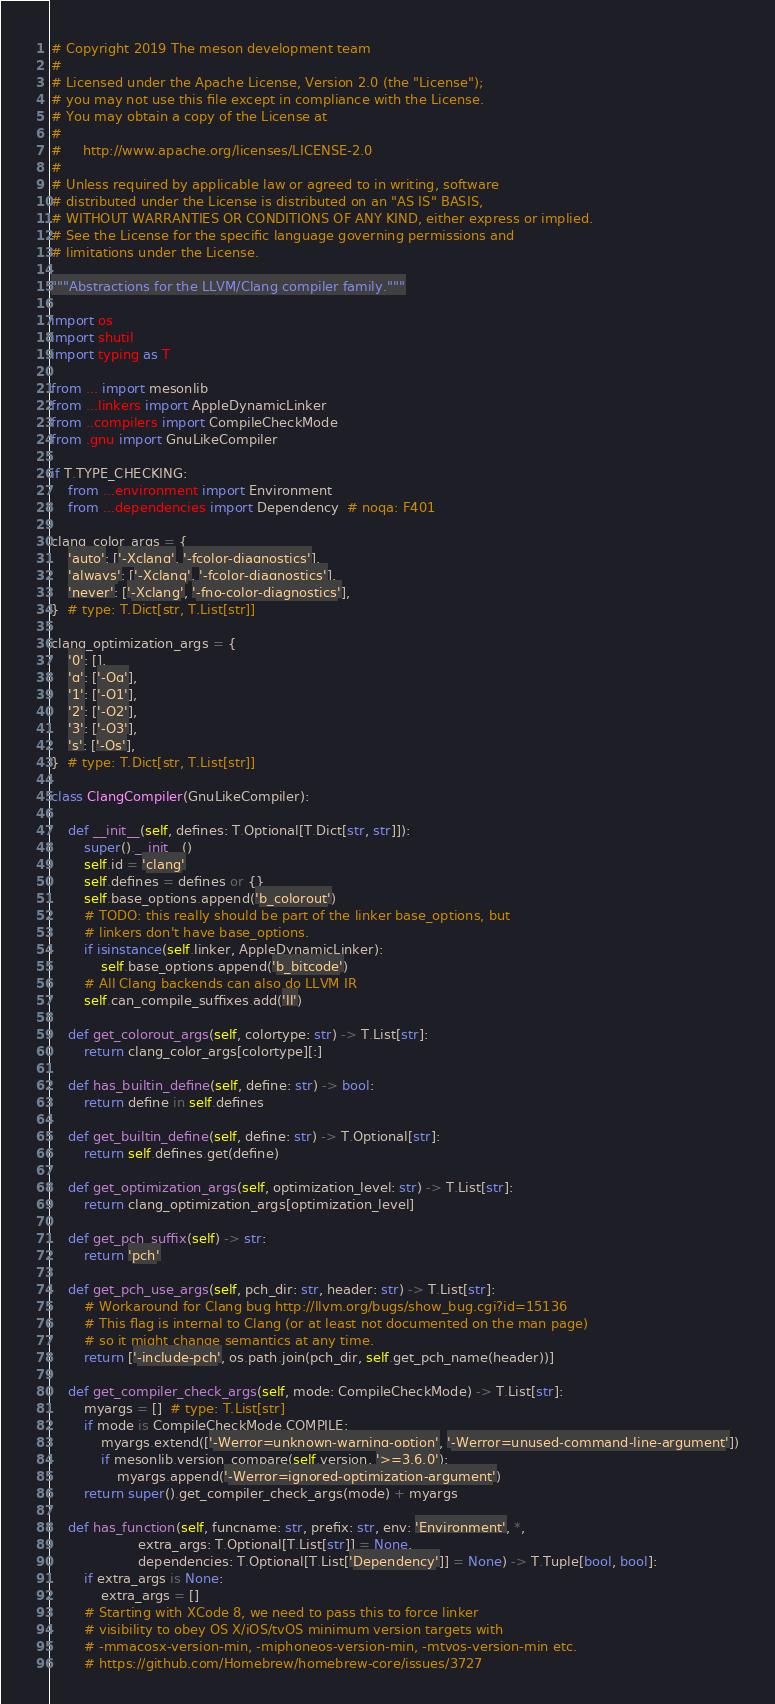Convert code to text. <code><loc_0><loc_0><loc_500><loc_500><_Python_># Copyright 2019 The meson development team
#
# Licensed under the Apache License, Version 2.0 (the "License");
# you may not use this file except in compliance with the License.
# You may obtain a copy of the License at
#
#     http://www.apache.org/licenses/LICENSE-2.0
#
# Unless required by applicable law or agreed to in writing, software
# distributed under the License is distributed on an "AS IS" BASIS,
# WITHOUT WARRANTIES OR CONDITIONS OF ANY KIND, either express or implied.
# See the License for the specific language governing permissions and
# limitations under the License.

"""Abstractions for the LLVM/Clang compiler family."""

import os
import shutil
import typing as T

from ... import mesonlib
from ...linkers import AppleDynamicLinker
from ..compilers import CompileCheckMode
from .gnu import GnuLikeCompiler

if T.TYPE_CHECKING:
    from ...environment import Environment
    from ...dependencies import Dependency  # noqa: F401

clang_color_args = {
    'auto': ['-Xclang', '-fcolor-diagnostics'],
    'always': ['-Xclang', '-fcolor-diagnostics'],
    'never': ['-Xclang', '-fno-color-diagnostics'],
}  # type: T.Dict[str, T.List[str]]

clang_optimization_args = {
    '0': [],
    'g': ['-Og'],
    '1': ['-O1'],
    '2': ['-O2'],
    '3': ['-O3'],
    's': ['-Os'],
}  # type: T.Dict[str, T.List[str]]

class ClangCompiler(GnuLikeCompiler):

    def __init__(self, defines: T.Optional[T.Dict[str, str]]):
        super().__init__()
        self.id = 'clang'
        self.defines = defines or {}
        self.base_options.append('b_colorout')
        # TODO: this really should be part of the linker base_options, but
        # linkers don't have base_options.
        if isinstance(self.linker, AppleDynamicLinker):
            self.base_options.append('b_bitcode')
        # All Clang backends can also do LLVM IR
        self.can_compile_suffixes.add('ll')

    def get_colorout_args(self, colortype: str) -> T.List[str]:
        return clang_color_args[colortype][:]

    def has_builtin_define(self, define: str) -> bool:
        return define in self.defines

    def get_builtin_define(self, define: str) -> T.Optional[str]:
        return self.defines.get(define)

    def get_optimization_args(self, optimization_level: str) -> T.List[str]:
        return clang_optimization_args[optimization_level]

    def get_pch_suffix(self) -> str:
        return 'pch'

    def get_pch_use_args(self, pch_dir: str, header: str) -> T.List[str]:
        # Workaround for Clang bug http://llvm.org/bugs/show_bug.cgi?id=15136
        # This flag is internal to Clang (or at least not documented on the man page)
        # so it might change semantics at any time.
        return ['-include-pch', os.path.join(pch_dir, self.get_pch_name(header))]

    def get_compiler_check_args(self, mode: CompileCheckMode) -> T.List[str]:
        myargs = []  # type: T.List[str]
        if mode is CompileCheckMode.COMPILE:
            myargs.extend(['-Werror=unknown-warning-option', '-Werror=unused-command-line-argument'])
            if mesonlib.version_compare(self.version, '>=3.6.0'):
                myargs.append('-Werror=ignored-optimization-argument')
        return super().get_compiler_check_args(mode) + myargs

    def has_function(self, funcname: str, prefix: str, env: 'Environment', *,
                     extra_args: T.Optional[T.List[str]] = None,
                     dependencies: T.Optional[T.List['Dependency']] = None) -> T.Tuple[bool, bool]:
        if extra_args is None:
            extra_args = []
        # Starting with XCode 8, we need to pass this to force linker
        # visibility to obey OS X/iOS/tvOS minimum version targets with
        # -mmacosx-version-min, -miphoneos-version-min, -mtvos-version-min etc.
        # https://github.com/Homebrew/homebrew-core/issues/3727</code> 